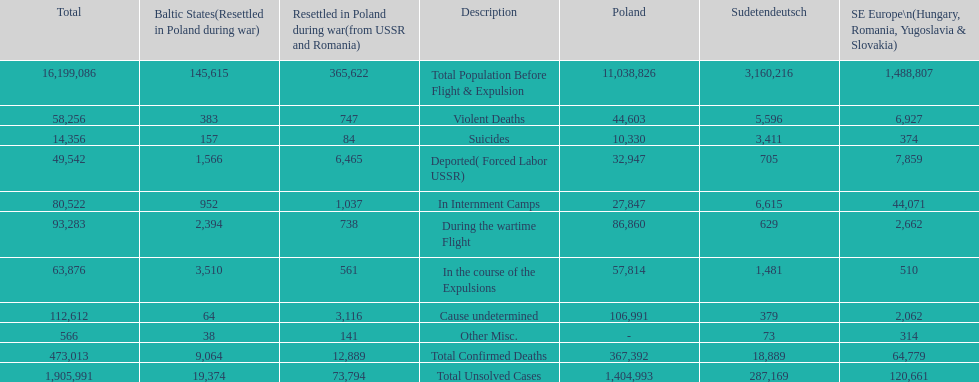Which country had the larger death tole? Poland. 